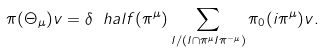<formula> <loc_0><loc_0><loc_500><loc_500>\pi ( \Theta _ { \mu } ) v = \delta ^ { \ } h a l f ( \pi ^ { \mu } ) \sum _ { I / ( I \cap \pi ^ { \mu } I \pi ^ { - \mu } ) } \pi _ { 0 } ( i \pi ^ { \mu } ) v .</formula> 